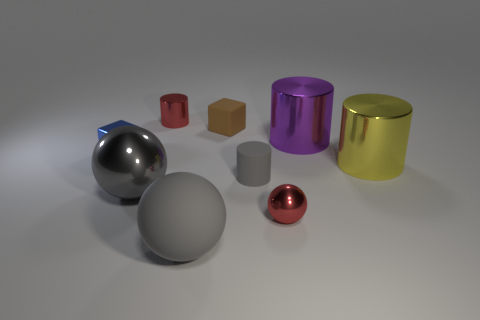What size is the metal cylinder to the left of the big gray object that is right of the sphere left of the tiny red cylinder?
Your answer should be compact. Small. The red metal object that is the same shape as the gray metal thing is what size?
Keep it short and to the point. Small. How many small things are either rubber cylinders or matte objects?
Provide a succinct answer. 2. Do the gray sphere that is behind the big matte thing and the red thing that is in front of the yellow metal object have the same material?
Your answer should be very brief. Yes. What is the material of the big object that is in front of the large gray metal object?
Provide a short and direct response. Rubber. How many rubber objects are either big things or big cyan cylinders?
Keep it short and to the point. 1. There is a big ball that is to the right of the metallic ball that is left of the big gray matte thing; what is its color?
Your response must be concise. Gray. Is the yellow thing made of the same material as the cube behind the large purple thing?
Provide a short and direct response. No. The shiny sphere to the left of the red shiny object that is in front of the tiny thing behind the small brown block is what color?
Provide a succinct answer. Gray. Are there any other things that are the same shape as the purple object?
Provide a succinct answer. Yes. 